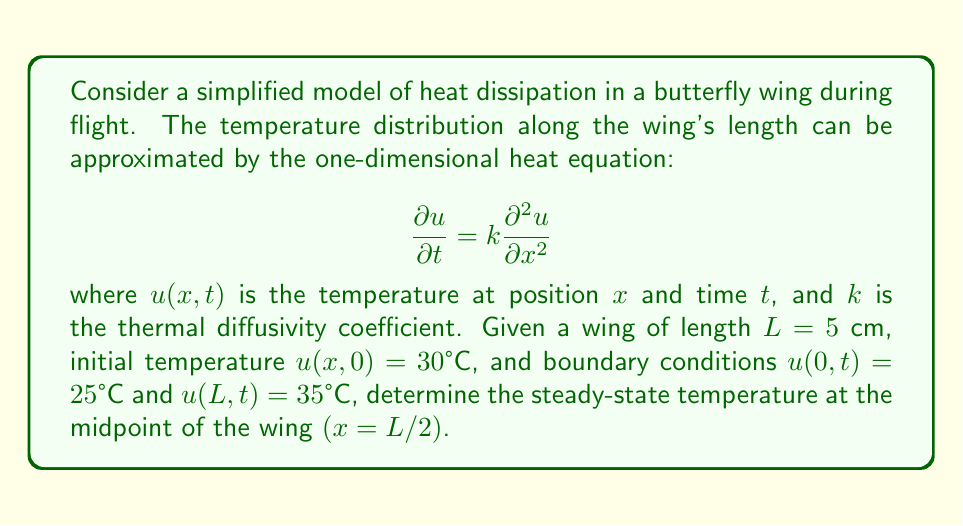Provide a solution to this math problem. To solve this problem, we'll follow these steps:

1) For the steady-state solution, the temperature doesn't change with time, so $\frac{\partial u}{\partial t} = 0$. The heat equation becomes:

   $$0 = k\frac{\partial^2 u}{\partial x^2}$$

2) Integrating twice with respect to $x$:

   $$u(x) = Ax + B$$

   where $A$ and $B$ are constants to be determined.

3) Apply the boundary conditions:
   At $x=0$: $u(0) = 25°C = B$
   At $x=L=5$ cm: $u(5) = 35°C = 5A + 25$

4) Solve for $A$:
   
   $$35 = 5A + 25$$
   $$A = 2$$

5) The steady-state temperature distribution is:

   $$u(x) = 2x + 25$$

6) To find the temperature at the midpoint $(x=L/2=2.5$ cm$)$:

   $$u(2.5) = 2(2.5) + 25 = 30°C$$

This solution mimics how heat dissipates along a butterfly's wing during flight, with cooler temperatures near the body and warmer temperatures at the wing tips due to air friction.
Answer: 30°C 